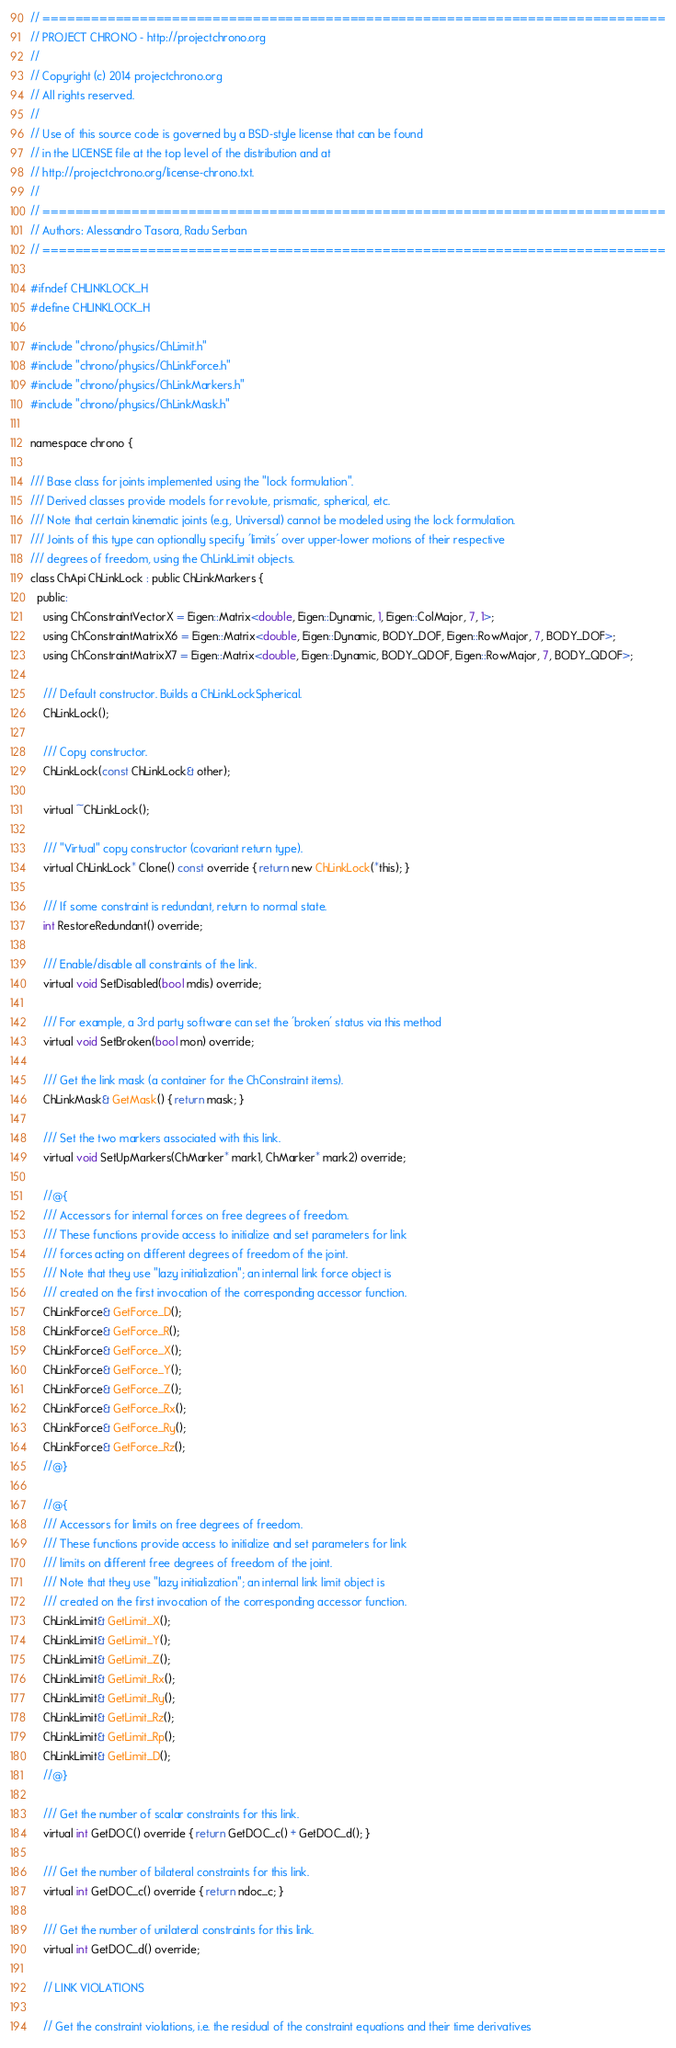<code> <loc_0><loc_0><loc_500><loc_500><_C_>// =============================================================================
// PROJECT CHRONO - http://projectchrono.org
//
// Copyright (c) 2014 projectchrono.org
// All rights reserved.
//
// Use of this source code is governed by a BSD-style license that can be found
// in the LICENSE file at the top level of the distribution and at
// http://projectchrono.org/license-chrono.txt.
//
// =============================================================================
// Authors: Alessandro Tasora, Radu Serban
// =============================================================================

#ifndef CHLINKLOCK_H
#define CHLINKLOCK_H

#include "chrono/physics/ChLimit.h"
#include "chrono/physics/ChLinkForce.h"
#include "chrono/physics/ChLinkMarkers.h"
#include "chrono/physics/ChLinkMask.h"

namespace chrono {

/// Base class for joints implemented using the "lock formulation".
/// Derived classes provide models for revolute, prismatic, spherical, etc.
/// Note that certain kinematic joints (e.g., Universal) cannot be modeled using the lock formulation.
/// Joints of this type can optionally specify 'limits' over upper-lower motions of their respective
/// degrees of freedom, using the ChLinkLimit objects.
class ChApi ChLinkLock : public ChLinkMarkers {
  public:
    using ChConstraintVectorX = Eigen::Matrix<double, Eigen::Dynamic, 1, Eigen::ColMajor, 7, 1>;
    using ChConstraintMatrixX6 = Eigen::Matrix<double, Eigen::Dynamic, BODY_DOF, Eigen::RowMajor, 7, BODY_DOF>;
    using ChConstraintMatrixX7 = Eigen::Matrix<double, Eigen::Dynamic, BODY_QDOF, Eigen::RowMajor, 7, BODY_QDOF>;

    /// Default constructor. Builds a ChLinkLockSpherical.
    ChLinkLock();

    /// Copy constructor.
    ChLinkLock(const ChLinkLock& other);

    virtual ~ChLinkLock();

    /// "Virtual" copy constructor (covariant return type).
    virtual ChLinkLock* Clone() const override { return new ChLinkLock(*this); }

    /// If some constraint is redundant, return to normal state.
    int RestoreRedundant() override;

    /// Enable/disable all constraints of the link.
    virtual void SetDisabled(bool mdis) override;

    /// For example, a 3rd party software can set the 'broken' status via this method
    virtual void SetBroken(bool mon) override;

    /// Get the link mask (a container for the ChConstraint items).
    ChLinkMask& GetMask() { return mask; }

    /// Set the two markers associated with this link.
    virtual void SetUpMarkers(ChMarker* mark1, ChMarker* mark2) override;

    //@{
    /// Accessors for internal forces on free degrees of freedom.
    /// These functions provide access to initialize and set parameters for link
    /// forces acting on different degrees of freedom of the joint.
    /// Note that they use "lazy initialization"; an internal link force object is
    /// created on the first invocation of the corresponding accessor function.
    ChLinkForce& GetForce_D();
    ChLinkForce& GetForce_R();
    ChLinkForce& GetForce_X();
    ChLinkForce& GetForce_Y();
    ChLinkForce& GetForce_Z();
    ChLinkForce& GetForce_Rx();
    ChLinkForce& GetForce_Ry();
    ChLinkForce& GetForce_Rz();
    //@}

    //@{
    /// Accessors for limits on free degrees of freedom.
    /// These functions provide access to initialize and set parameters for link
    /// limits on different free degrees of freedom of the joint.
    /// Note that they use "lazy initialization"; an internal link limit object is
    /// created on the first invocation of the corresponding accessor function.
    ChLinkLimit& GetLimit_X();
    ChLinkLimit& GetLimit_Y();
    ChLinkLimit& GetLimit_Z();
    ChLinkLimit& GetLimit_Rx();
    ChLinkLimit& GetLimit_Ry();
    ChLinkLimit& GetLimit_Rz();
    ChLinkLimit& GetLimit_Rp();
    ChLinkLimit& GetLimit_D();
    //@}

    /// Get the number of scalar constraints for this link.
    virtual int GetDOC() override { return GetDOC_c() + GetDOC_d(); }

    /// Get the number of bilateral constraints for this link.
    virtual int GetDOC_c() override { return ndoc_c; }

    /// Get the number of unilateral constraints for this link.
    virtual int GetDOC_d() override;

    // LINK VIOLATIONS

    // Get the constraint violations, i.e. the residual of the constraint equations and their time derivatives
</code> 